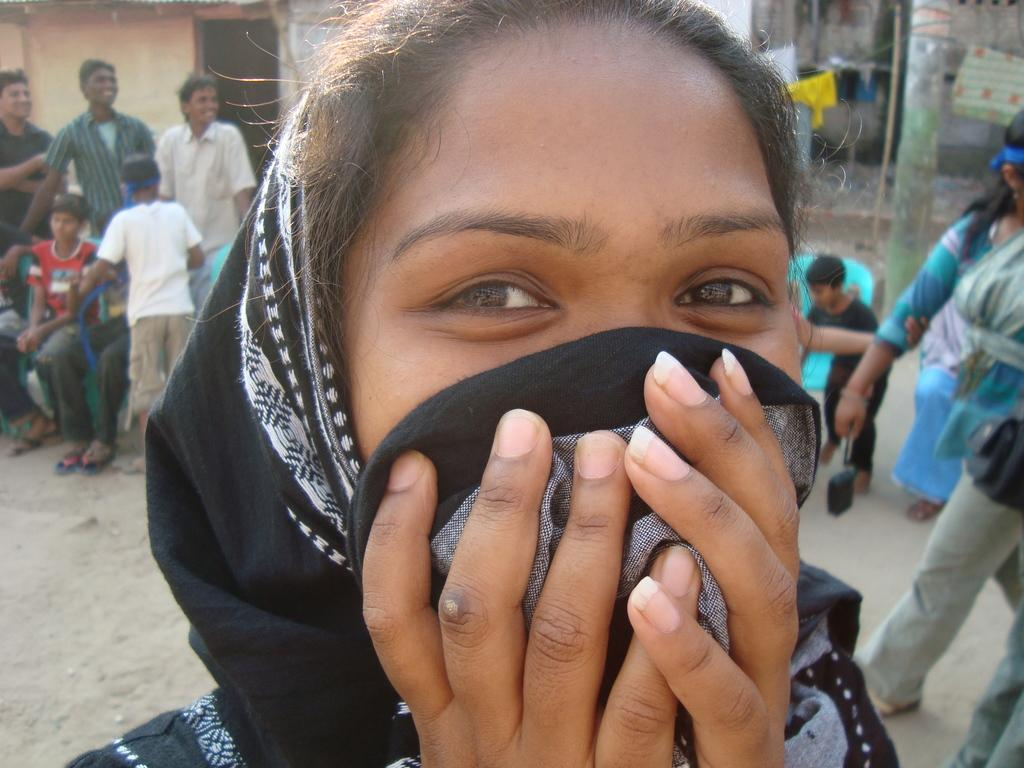What is the main subject of the image? There is a woman's face in the center of the image. What can be seen in the background of the image? There are persons, a pole, and buildings in the background of the image. What type of doll is being blown by the wind in the image? There is no doll present in the image, nor is there any wind blowing anything. 